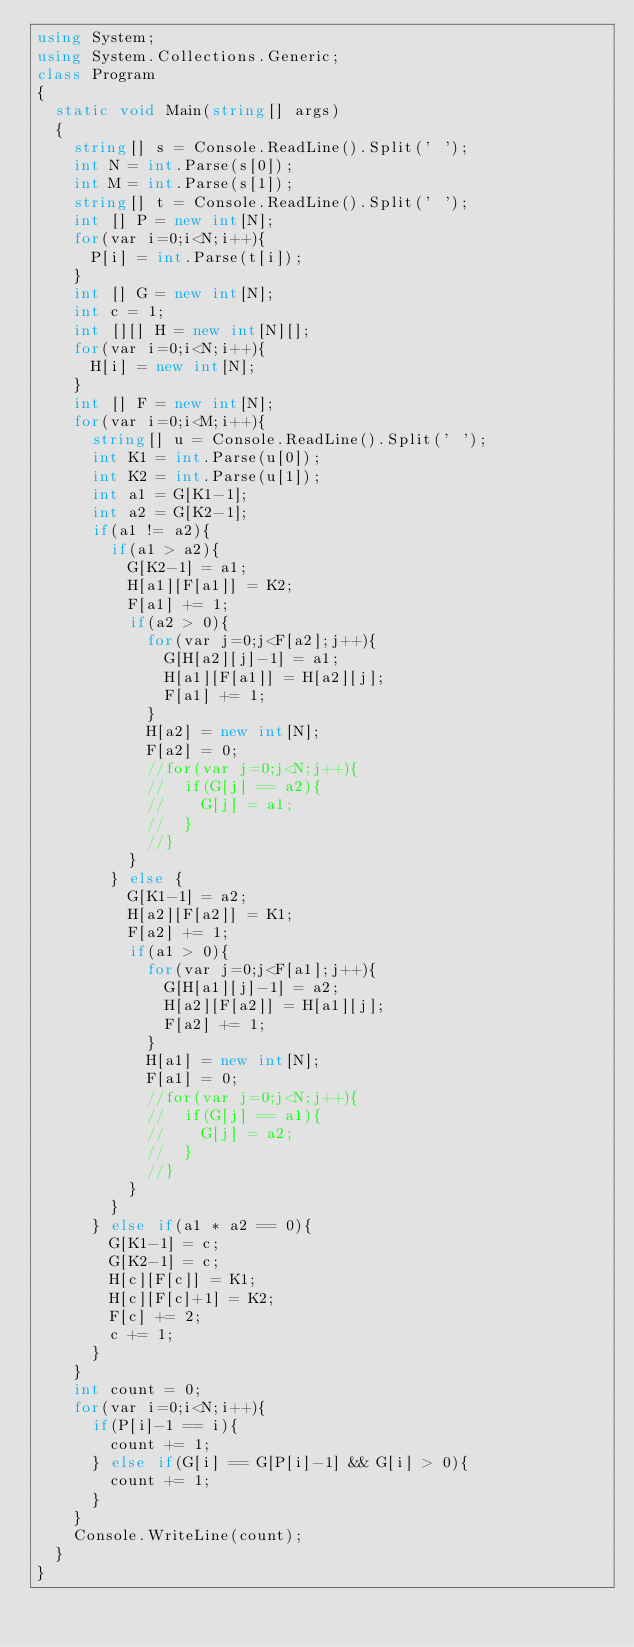<code> <loc_0><loc_0><loc_500><loc_500><_C#_>using System;
using System.Collections.Generic;
class Program
{
	static void Main(string[] args)
	{
		string[] s = Console.ReadLine().Split(' ');
		int N = int.Parse(s[0]);
		int M = int.Parse(s[1]);
		string[] t = Console.ReadLine().Split(' ');
		int [] P = new int[N];
		for(var i=0;i<N;i++){
			P[i] = int.Parse(t[i]);
		}
		int [] G = new int[N];
		int c = 1;
		int [][] H = new int[N][];
		for(var i=0;i<N;i++){
			H[i] = new int[N];
		}
		int [] F = new int[N];
		for(var i=0;i<M;i++){
			string[] u = Console.ReadLine().Split(' ');
			int K1 = int.Parse(u[0]);
			int K2 = int.Parse(u[1]);
			int a1 = G[K1-1];
			int a2 = G[K2-1];
			if(a1 != a2){
				if(a1 > a2){
					G[K2-1] = a1;
					H[a1][F[a1]] = K2;
					F[a1] += 1;
					if(a2 > 0){
						for(var j=0;j<F[a2];j++){
							G[H[a2][j]-1] = a1;
							H[a1][F[a1]] = H[a2][j];
							F[a1] += 1;
						}
						H[a2] = new int[N];
						F[a2] = 0;
						//for(var j=0;j<N;j++){
						//	if(G[j] == a2){
						//		G[j] = a1;
						//	}
						//}
					}
				} else {
					G[K1-1] = a2;
					H[a2][F[a2]] = K1;
					F[a2] += 1;
					if(a1 > 0){
						for(var j=0;j<F[a1];j++){
							G[H[a1][j]-1] = a2;
							H[a2][F[a2]] = H[a1][j];
							F[a2] += 1;
						}
						H[a1] = new int[N];
						F[a1] = 0;
						//for(var j=0;j<N;j++){
						//	if(G[j] == a1){
						//		G[j] = a2;
						//	}
						//}
					}
				}
			} else if(a1 * a2 == 0){
				G[K1-1] = c;
				G[K2-1] = c;
				H[c][F[c]] = K1;
				H[c][F[c]+1] = K2;
				F[c] += 2;
				c += 1;
			}
		}
		int count = 0;
		for(var i=0;i<N;i++){
			if(P[i]-1 == i){
				count += 1;
			} else if(G[i] == G[P[i]-1] && G[i] > 0){
				count += 1;
			}
		}
		Console.WriteLine(count);
	}
}</code> 